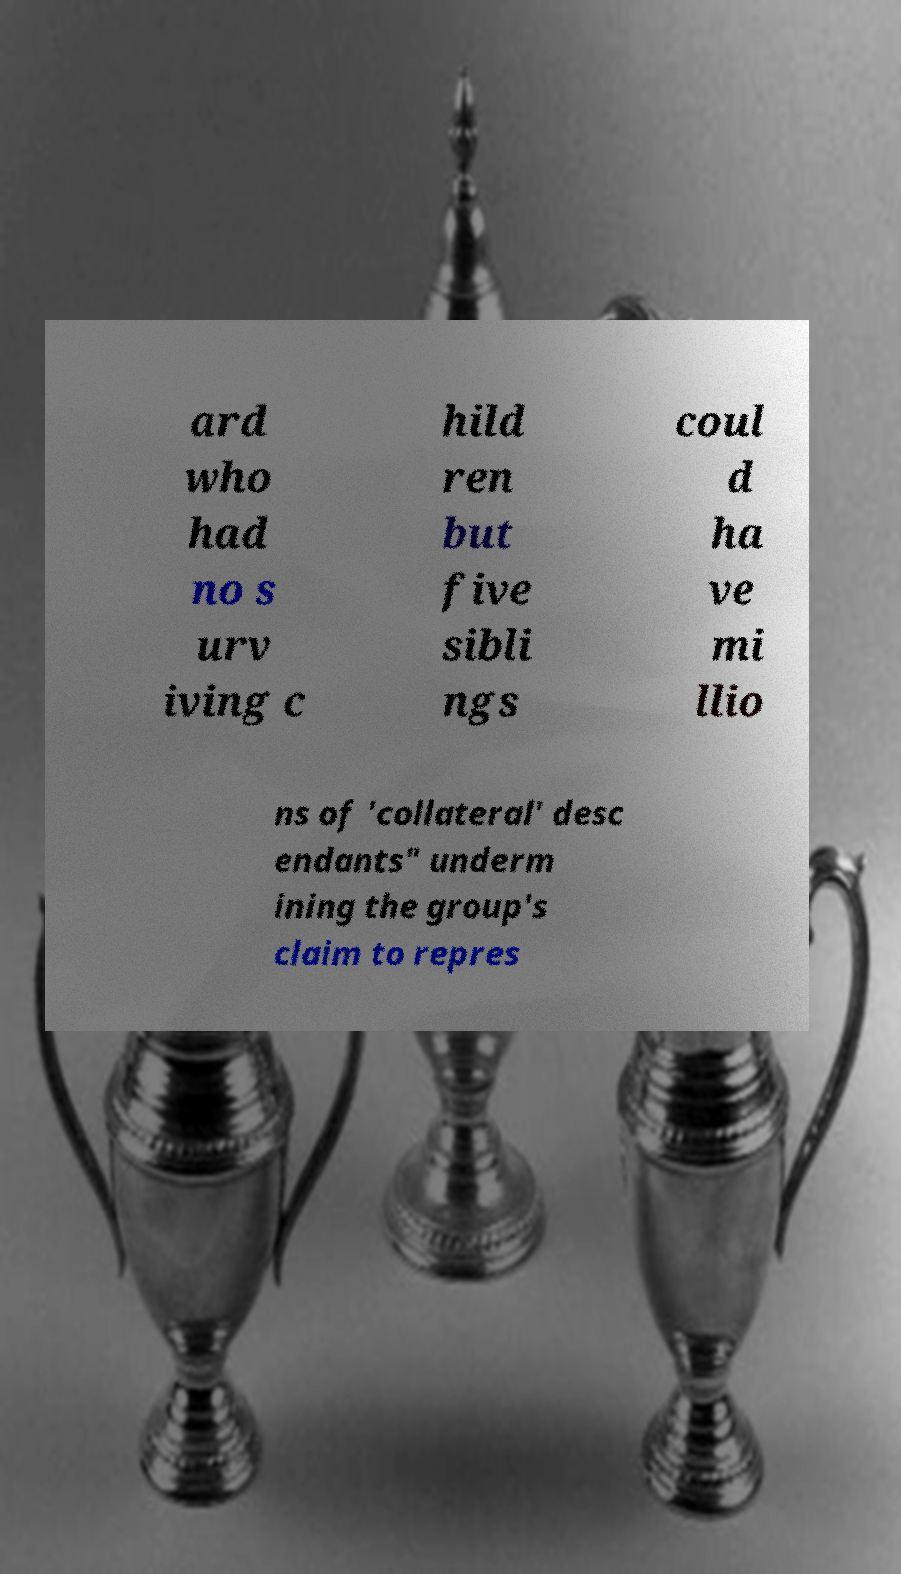Please identify and transcribe the text found in this image. ard who had no s urv iving c hild ren but five sibli ngs coul d ha ve mi llio ns of 'collateral' desc endants" underm ining the group's claim to repres 